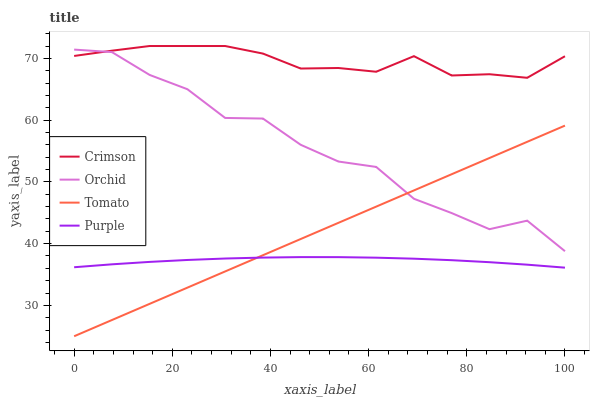Does Purple have the minimum area under the curve?
Answer yes or no. Yes. Does Crimson have the maximum area under the curve?
Answer yes or no. Yes. Does Tomato have the minimum area under the curve?
Answer yes or no. No. Does Tomato have the maximum area under the curve?
Answer yes or no. No. Is Tomato the smoothest?
Answer yes or no. Yes. Is Orchid the roughest?
Answer yes or no. Yes. Is Purple the smoothest?
Answer yes or no. No. Is Purple the roughest?
Answer yes or no. No. Does Tomato have the lowest value?
Answer yes or no. Yes. Does Purple have the lowest value?
Answer yes or no. No. Does Crimson have the highest value?
Answer yes or no. Yes. Does Tomato have the highest value?
Answer yes or no. No. Is Purple less than Crimson?
Answer yes or no. Yes. Is Crimson greater than Tomato?
Answer yes or no. Yes. Does Purple intersect Tomato?
Answer yes or no. Yes. Is Purple less than Tomato?
Answer yes or no. No. Is Purple greater than Tomato?
Answer yes or no. No. Does Purple intersect Crimson?
Answer yes or no. No. 